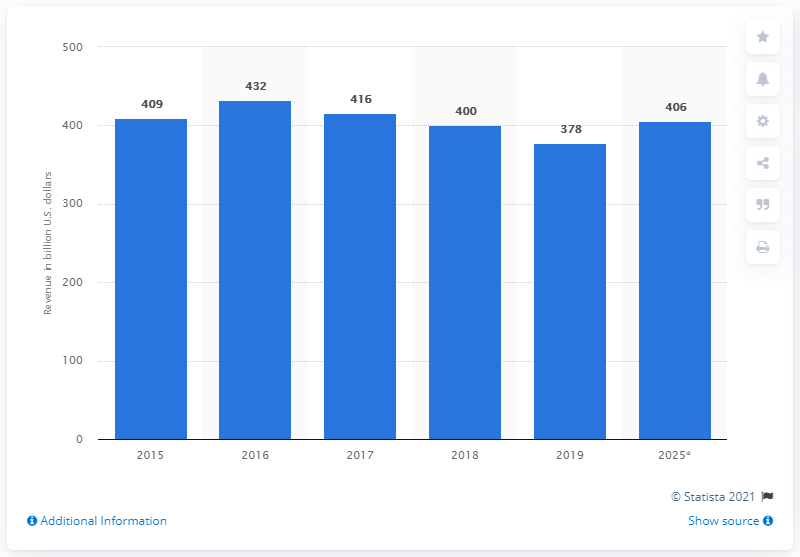Identify some key points in this picture. It is projected that the revenue of mobile operators in the Asia Pacific region will reach 406 by 2025. The revenue generated by mobile operators in the Asia Pacific region in 2019 was approximately 378 billion U.S. dollars. 